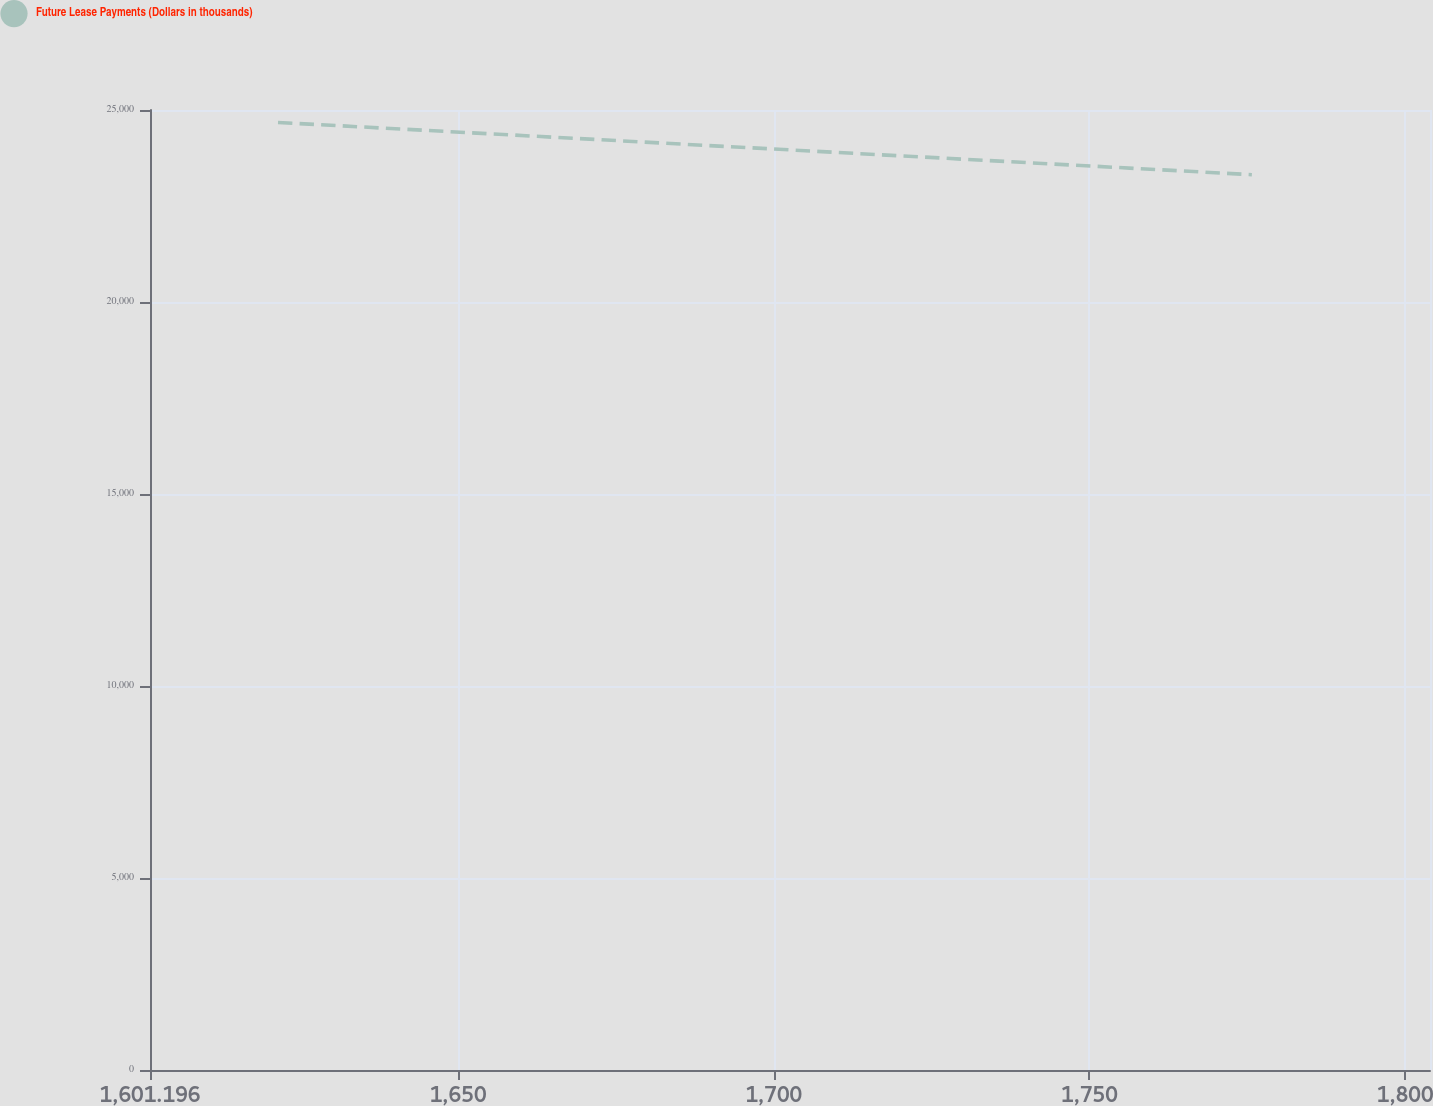Convert chart to OTSL. <chart><loc_0><loc_0><loc_500><loc_500><line_chart><ecel><fcel>Future Lease Payments (Dollars in thousands)<nl><fcel>1621.47<fcel>24676<nl><fcel>1775.72<fcel>23315.6<nl><fcel>1804.62<fcel>18943.7<nl><fcel>1824.21<fcel>13451.6<nl></chart> 